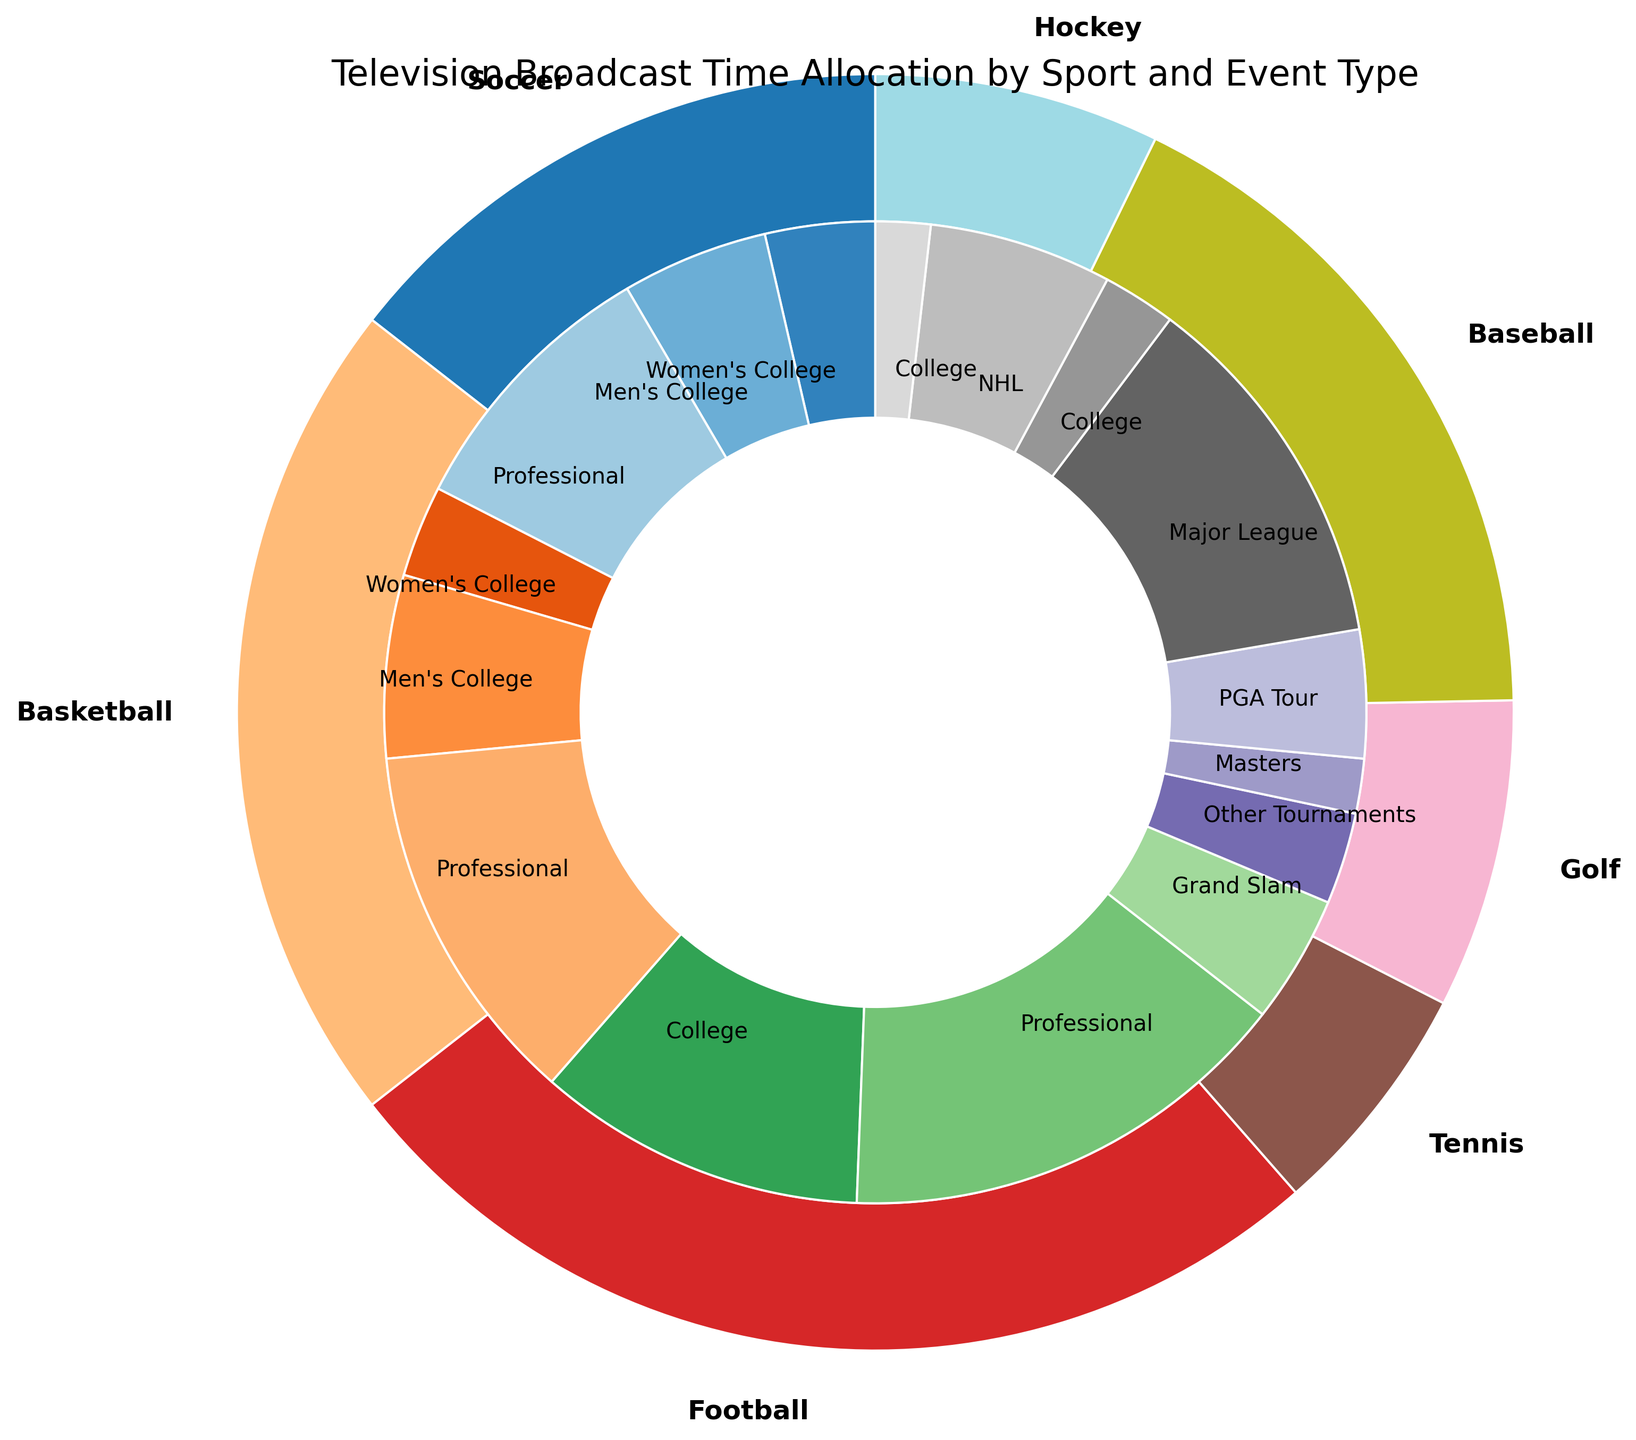Which sport has the highest total broadcast time? To find the sport with the highest total broadcast time, we need to look at where the largest segment in the outer ring is. In the plot, the largest segment is for Football.
Answer: Football How much more broadcast time does professional soccer have compared to women's college soccer? First, identify the broadcast times for both professional soccer (150 hours) and women's college soccer (60 hours) from the inner ring. Then, subtract the women's college soccer time from the professional soccer time: 150 - 60 = 90 hours.
Answer: 90 hours Which has less broadcast time: college basketball or professional hockey? Look at the inner pie segments for college basketball and professional hockey. College basketball has 50 + 100 = 150 hours, and professional hockey has 100 hours. Compare these two values: professional hockey has less broadcast time.
Answer: Professional hockey What's the total broadcast time for all tennis events? Identify the segments for Grand Slam (70 hours) and Other Tournaments (50 hours) from the inner ring for tennis. Add these times together: 70 + 50 = 120 hours.
Answer: 120 hours Which color represents soccer in the outer ring, and what are the respective broadcast times for each soccer event type? Look at the outer ring to identify the color assigned to soccer. Then refer to the inner ring segments within this color: Women's College (60 hours), Men's College (80 hours), and Professional (150 hours).
Answer: Varies by figure but typically blueish. Women's College: 60 hours, Men's College: 80 hours, Professional: 150 hours 